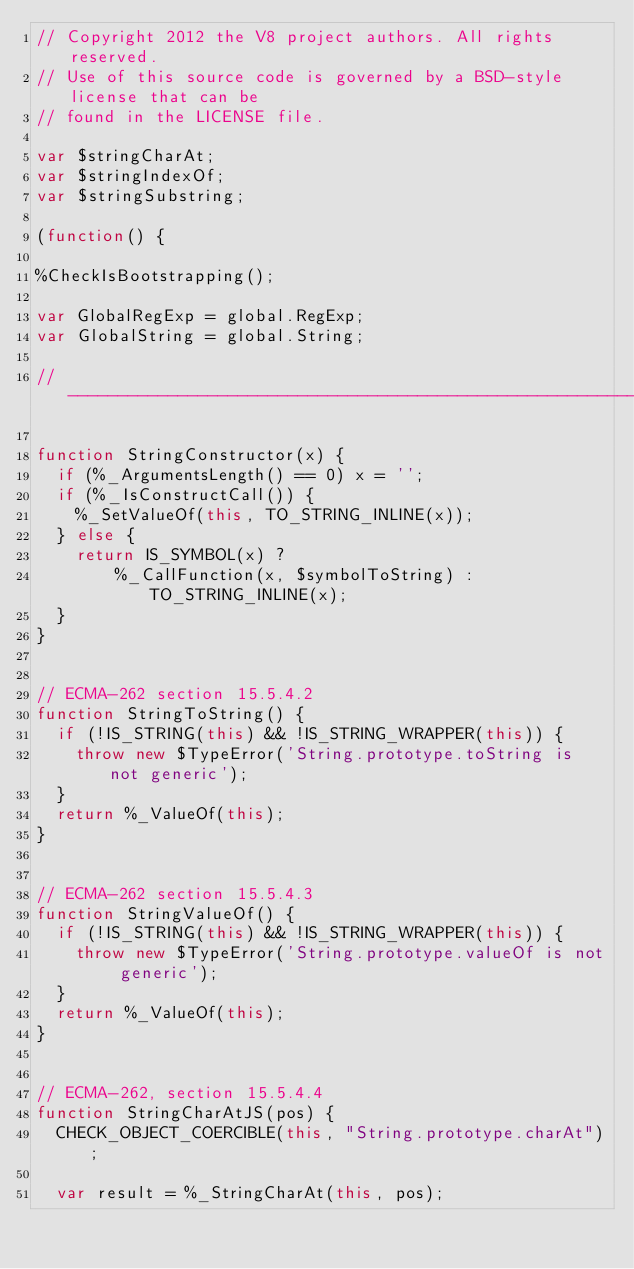<code> <loc_0><loc_0><loc_500><loc_500><_JavaScript_>// Copyright 2012 the V8 project authors. All rights reserved.
// Use of this source code is governed by a BSD-style license that can be
// found in the LICENSE file.

var $stringCharAt;
var $stringIndexOf;
var $stringSubstring;

(function() {

%CheckIsBootstrapping();

var GlobalRegExp = global.RegExp;
var GlobalString = global.String;

//-------------------------------------------------------------------

function StringConstructor(x) {
  if (%_ArgumentsLength() == 0) x = '';
  if (%_IsConstructCall()) {
    %_SetValueOf(this, TO_STRING_INLINE(x));
  } else {
    return IS_SYMBOL(x) ?
        %_CallFunction(x, $symbolToString) : TO_STRING_INLINE(x);
  }
}


// ECMA-262 section 15.5.4.2
function StringToString() {
  if (!IS_STRING(this) && !IS_STRING_WRAPPER(this)) {
    throw new $TypeError('String.prototype.toString is not generic');
  }
  return %_ValueOf(this);
}


// ECMA-262 section 15.5.4.3
function StringValueOf() {
  if (!IS_STRING(this) && !IS_STRING_WRAPPER(this)) {
    throw new $TypeError('String.prototype.valueOf is not generic');
  }
  return %_ValueOf(this);
}


// ECMA-262, section 15.5.4.4
function StringCharAtJS(pos) {
  CHECK_OBJECT_COERCIBLE(this, "String.prototype.charAt");

  var result = %_StringCharAt(this, pos);</code> 